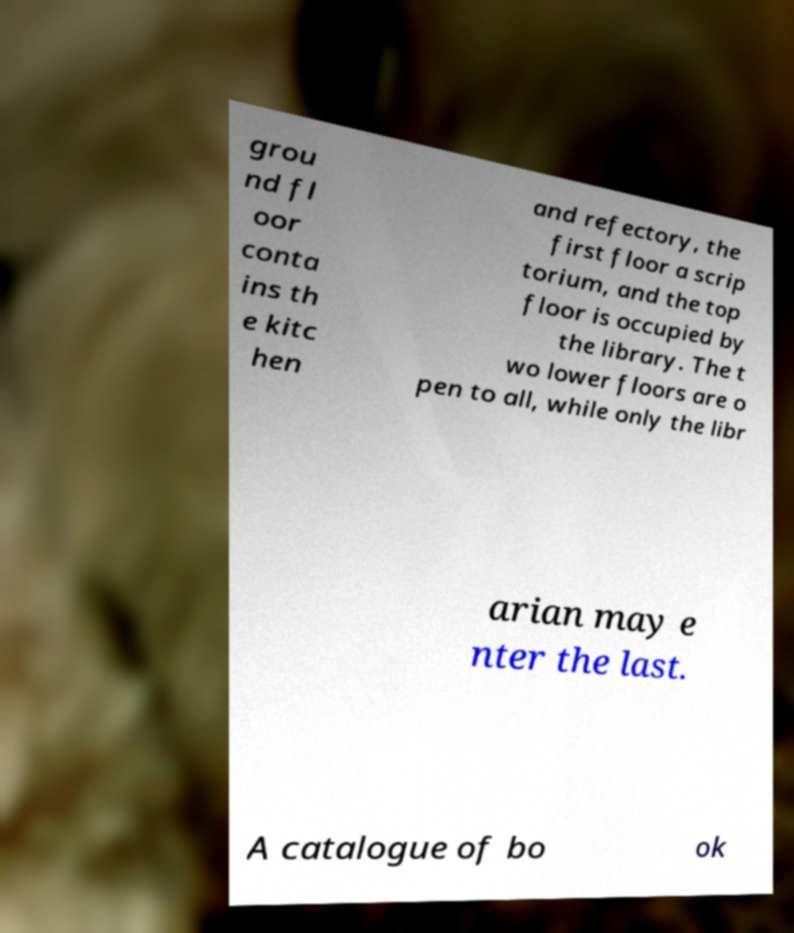For documentation purposes, I need the text within this image transcribed. Could you provide that? grou nd fl oor conta ins th e kitc hen and refectory, the first floor a scrip torium, and the top floor is occupied by the library. The t wo lower floors are o pen to all, while only the libr arian may e nter the last. A catalogue of bo ok 